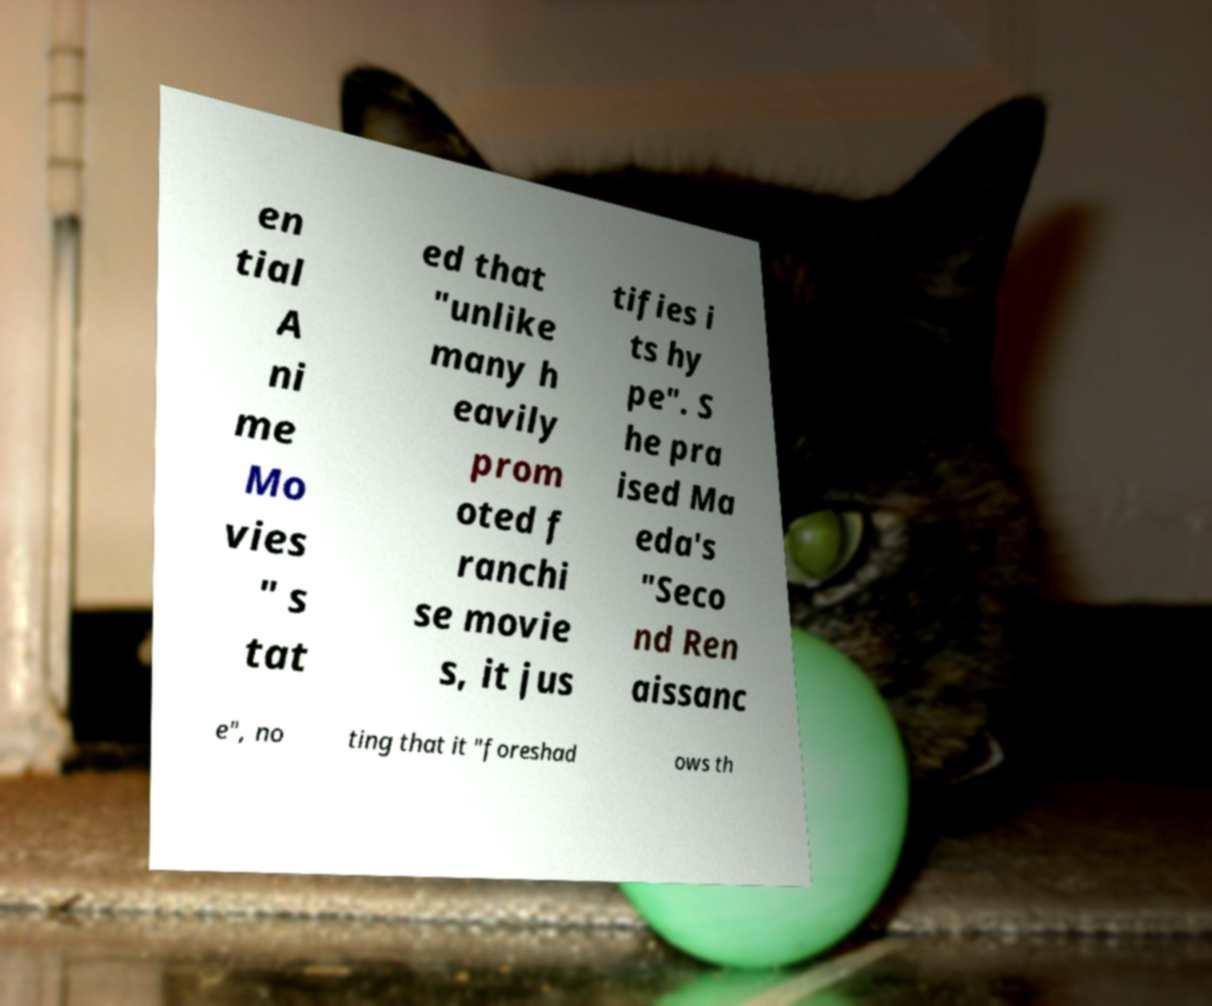Could you extract and type out the text from this image? en tial A ni me Mo vies " s tat ed that "unlike many h eavily prom oted f ranchi se movie s, it jus tifies i ts hy pe". S he pra ised Ma eda's "Seco nd Ren aissanc e", no ting that it "foreshad ows th 